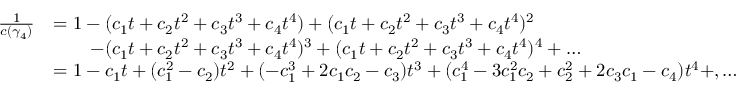Convert formula to latex. <formula><loc_0><loc_0><loc_500><loc_500>\begin{array} { r l } { \frac { 1 } { c ( \gamma _ { 4 } ) } } & { = 1 - ( c _ { 1 } t + c _ { 2 } t ^ { 2 } + c _ { 3 } t ^ { 3 } + c _ { 4 } t ^ { 4 } ) + ( c _ { 1 } t + c _ { 2 } t ^ { 2 } + c _ { 3 } t ^ { 3 } + c _ { 4 } t ^ { 4 } ) ^ { 2 } } \\ & { \, - ( c _ { 1 } t + c _ { 2 } t ^ { 2 } + c _ { 3 } t ^ { 3 } + c _ { 4 } t ^ { 4 } ) ^ { 3 } + ( c _ { 1 } t + c _ { 2 } t ^ { 2 } + c _ { 3 } t ^ { 3 } + c _ { 4 } t ^ { 4 } ) ^ { 4 } + \dots } \\ & { = 1 - c _ { 1 } t + ( c _ { 1 } ^ { 2 } - c _ { 2 } ) t ^ { 2 } + ( - c _ { 1 } ^ { 3 } + 2 c _ { 1 } c _ { 2 } - c _ { 3 } ) t ^ { 3 } + ( c _ { 1 } ^ { 4 } - 3 c _ { 1 } ^ { 2 } c _ { 2 } + c _ { 2 } ^ { 2 } + 2 c _ { 3 } c _ { 1 } - c _ { 4 } ) t ^ { 4 } + , \dots } \end{array}</formula> 